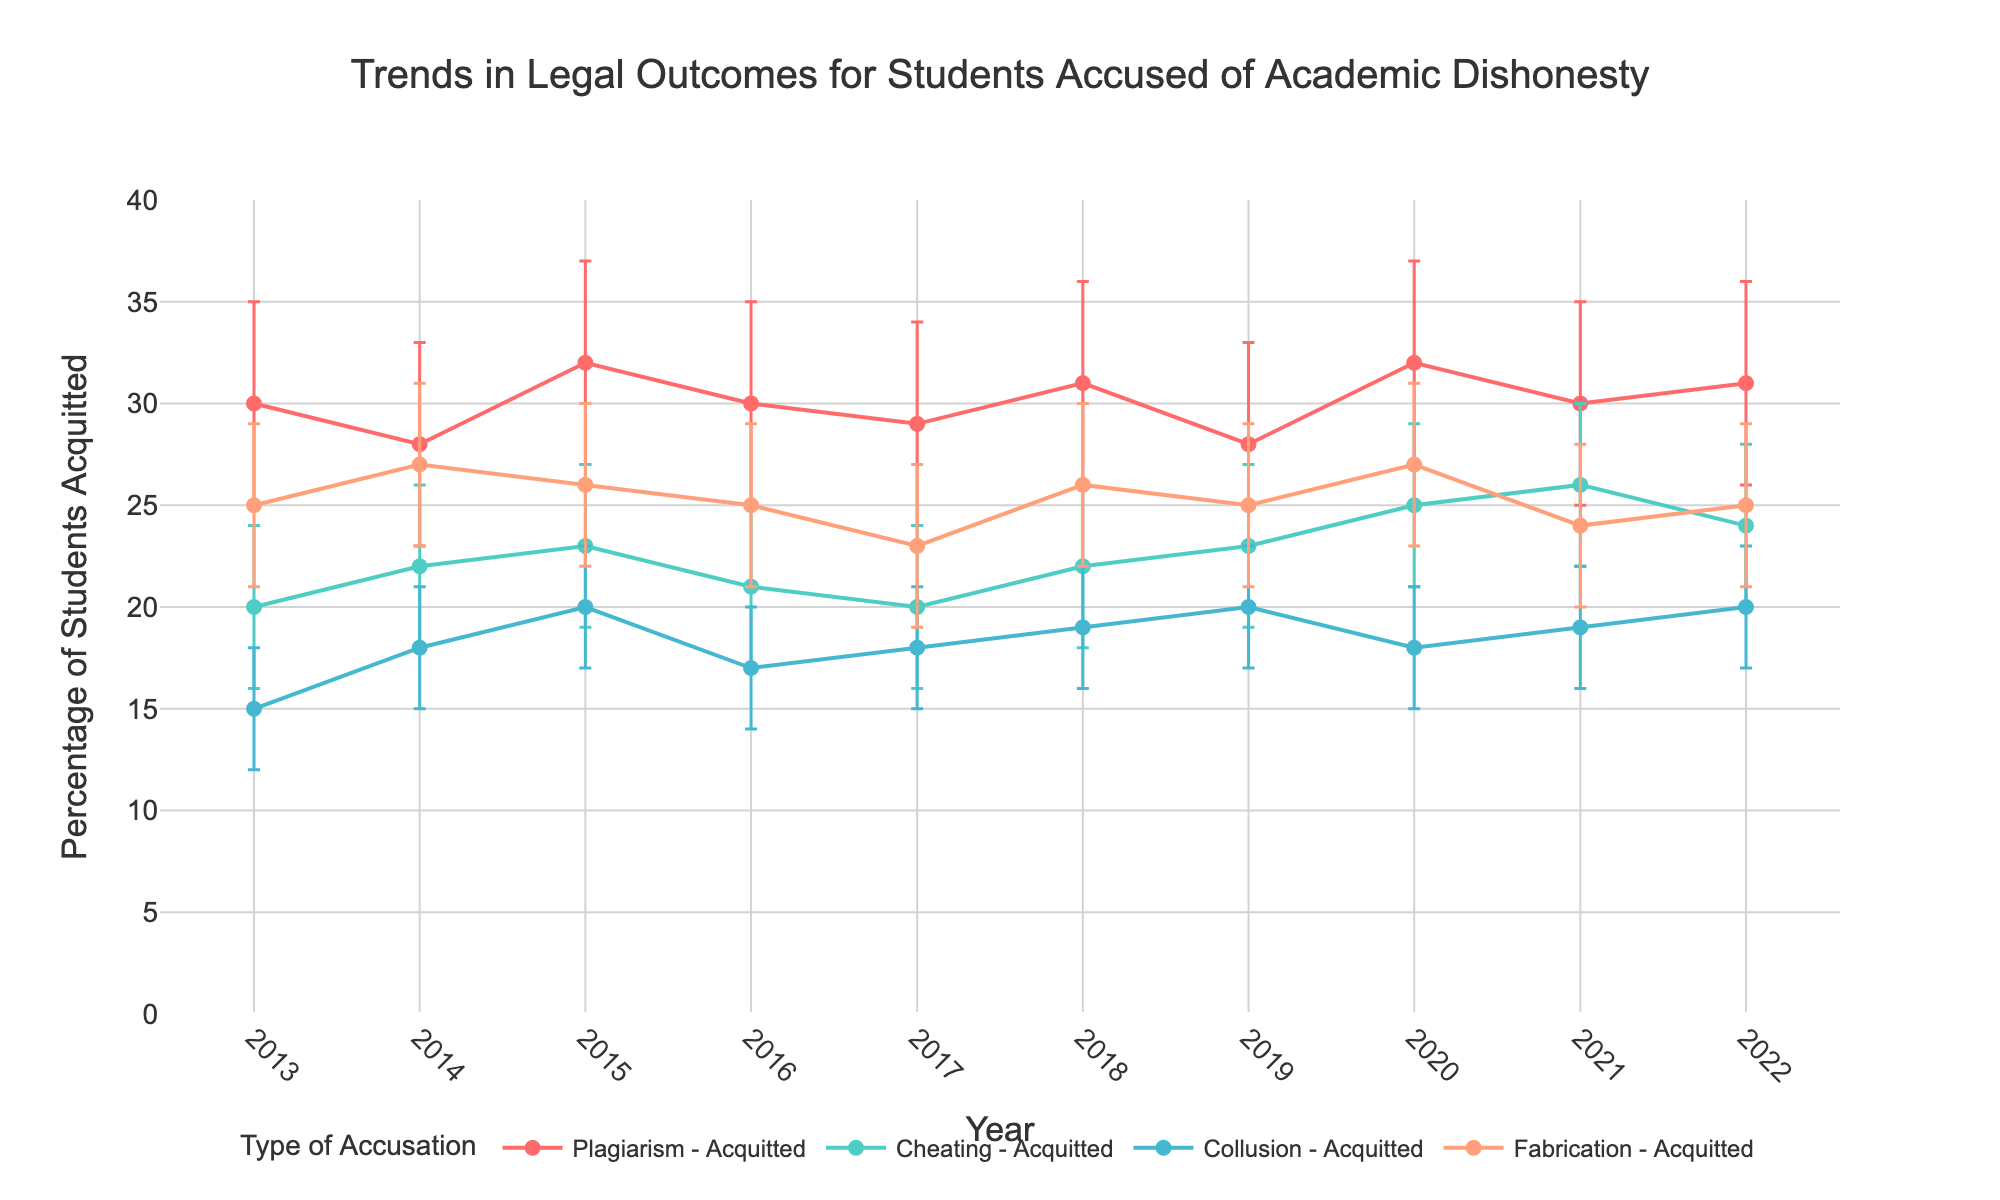What is the title of the plot? The title of the plot is located at the top and is the most prominent text in the figure.
Answer: "Trends in Legal Outcomes for Students Accused of Academic Dishonesty" What is the y-axis title? The y-axis title is located along the vertical axis on the left side of the plot.
Answer: "Percentage of Students Acquitted" How many types of accusations are displayed in the plot? There are distinct lines in the plot, each representing a different type of accusation. Counting these distinct lines gives the number of types of accusations.
Answer: 4 Which accusation type has the highest percentage of students acquitted in 2020? Locate the year 2020 on the x-axis, then identify which line reaches the highest point on the y-axis for that year.
Answer: Cheating What was the trend for the percentage of students acquitted of plagiarism from 2013 to 2022? Follow the line corresponding to plagiarism from 2013 to 2022 and observe whether it generally increases, decreases, or stays constant.
Answer: Slightly fluctuating but generally increasing Looking at 2016, which accusation type had the lowest percentage of students acquitted and what was it? Identify the year 2016 on the x-axis, then look for the lowest point among all lines corresponding to different accusation types.
Answer: Collusion, 17% How did the percentage of students acquitted of fabrication change between 2014 and 2018? Locate the points for fabrication at 2014 and 2018, and observe the change in their y-axis values.
Answer: Slight increase How does the error bar length for plagiarism in 2021 compare to that in 2022? Compare the length of the vertical error bars for the plagiarism line in 2021 and 2022.
Answer: The same In which year did collusion have the highest percentage of students acquitted, and what was the approximate percentage? Locate the highest point on the collusion line and identify its corresponding year and y-axis value.
Answer: 2022, approximately 20% Which accusation type shows the most consistent percentage of acquitted students across the years? Observe all accusation lines for stability in their y-axis positions across the years.
Answer: Collusion 